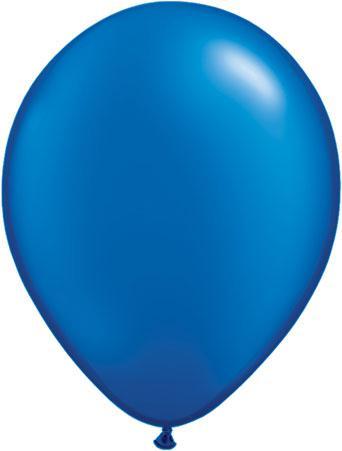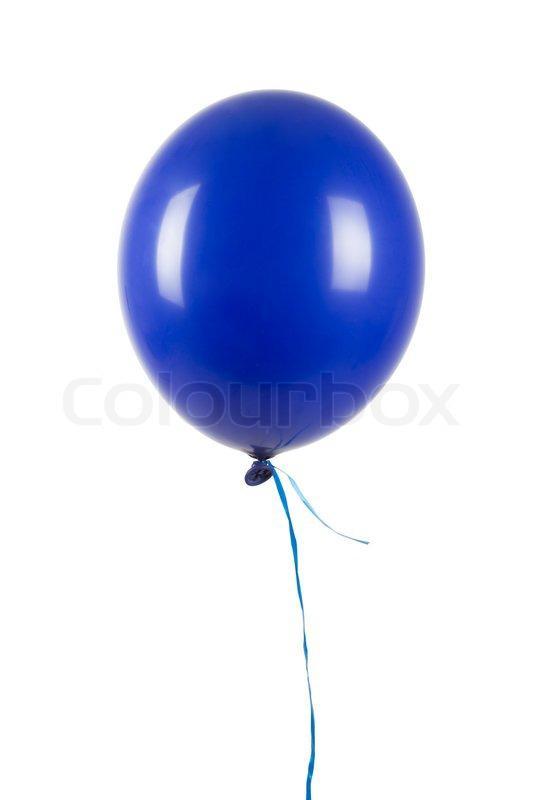The first image is the image on the left, the second image is the image on the right. Evaluate the accuracy of this statement regarding the images: "the image on the right contains one round balloon on a white background". Is it true? Answer yes or no. Yes. 